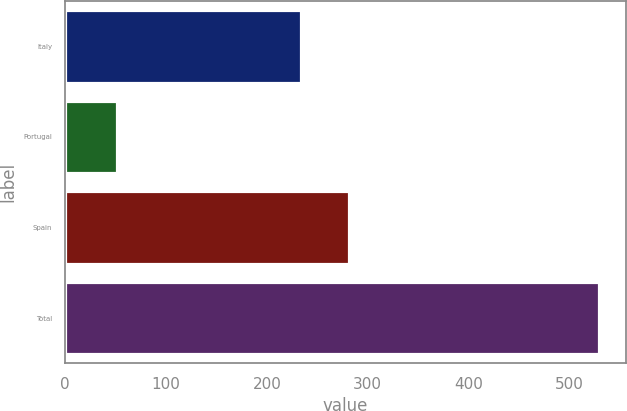Convert chart to OTSL. <chart><loc_0><loc_0><loc_500><loc_500><bar_chart><fcel>Italy<fcel>Portugal<fcel>Spain<fcel>Total<nl><fcel>233.4<fcel>50.9<fcel>281.28<fcel>529.7<nl></chart> 